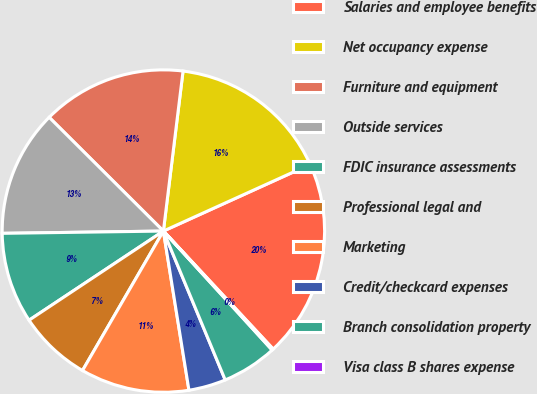Convert chart to OTSL. <chart><loc_0><loc_0><loc_500><loc_500><pie_chart><fcel>Salaries and employee benefits<fcel>Net occupancy expense<fcel>Furniture and equipment<fcel>Outside services<fcel>FDIC insurance assessments<fcel>Professional legal and<fcel>Marketing<fcel>Credit/checkcard expenses<fcel>Branch consolidation property<fcel>Visa class B shares expense<nl><fcel>19.86%<fcel>16.27%<fcel>14.48%<fcel>12.69%<fcel>9.1%<fcel>7.31%<fcel>10.9%<fcel>3.73%<fcel>5.52%<fcel>0.14%<nl></chart> 